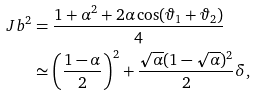Convert formula to latex. <formula><loc_0><loc_0><loc_500><loc_500>\ J b ^ { 2 } & = \frac { 1 + \alpha ^ { 2 } + 2 \alpha \cos ( \vartheta _ { 1 } + \vartheta _ { 2 } ) } { 4 } \\ & \simeq \left ( \frac { 1 - \alpha } { 2 } \right ) ^ { 2 } + \frac { \sqrt { \alpha } ( 1 - \sqrt { \alpha } ) ^ { 2 } } { 2 } \delta ,</formula> 